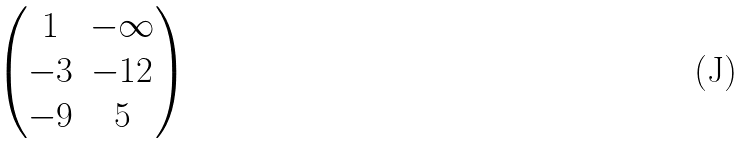Convert formula to latex. <formula><loc_0><loc_0><loc_500><loc_500>\begin{pmatrix} 1 & - \infty \\ - 3 & - 1 2 \\ - 9 & 5 \end{pmatrix}</formula> 